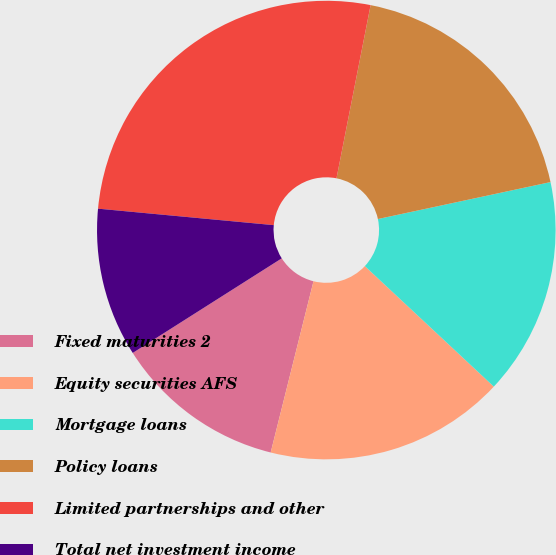Convert chart to OTSL. <chart><loc_0><loc_0><loc_500><loc_500><pie_chart><fcel>Fixed maturities 2<fcel>Equity securities AFS<fcel>Mortgage loans<fcel>Policy loans<fcel>Limited partnerships and other<fcel>Total net investment income<nl><fcel>12.1%<fcel>16.94%<fcel>15.32%<fcel>18.55%<fcel>26.61%<fcel>10.49%<nl></chart> 